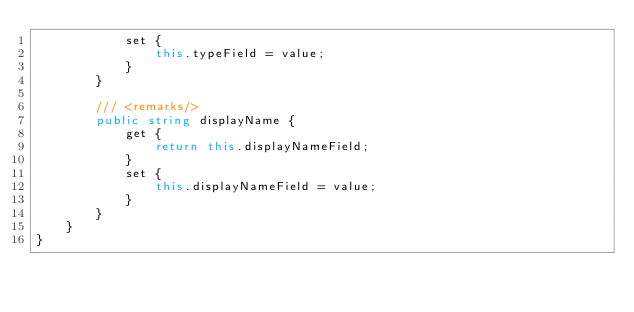<code> <loc_0><loc_0><loc_500><loc_500><_C#_>            set {
                this.typeField = value;
            }
        }
    
        /// <remarks/>
        public string displayName {
            get {
                return this.displayNameField;
            }
            set {
                this.displayNameField = value;
            }
        }
    }
}</code> 